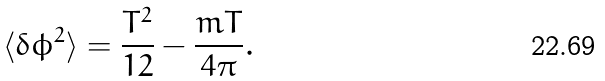<formula> <loc_0><loc_0><loc_500><loc_500>\langle \delta \phi ^ { 2 } \rangle = \frac { T ^ { 2 } } { 1 2 } - \frac { m T } { 4 \pi } .</formula> 